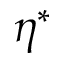<formula> <loc_0><loc_0><loc_500><loc_500>\eta ^ { * }</formula> 